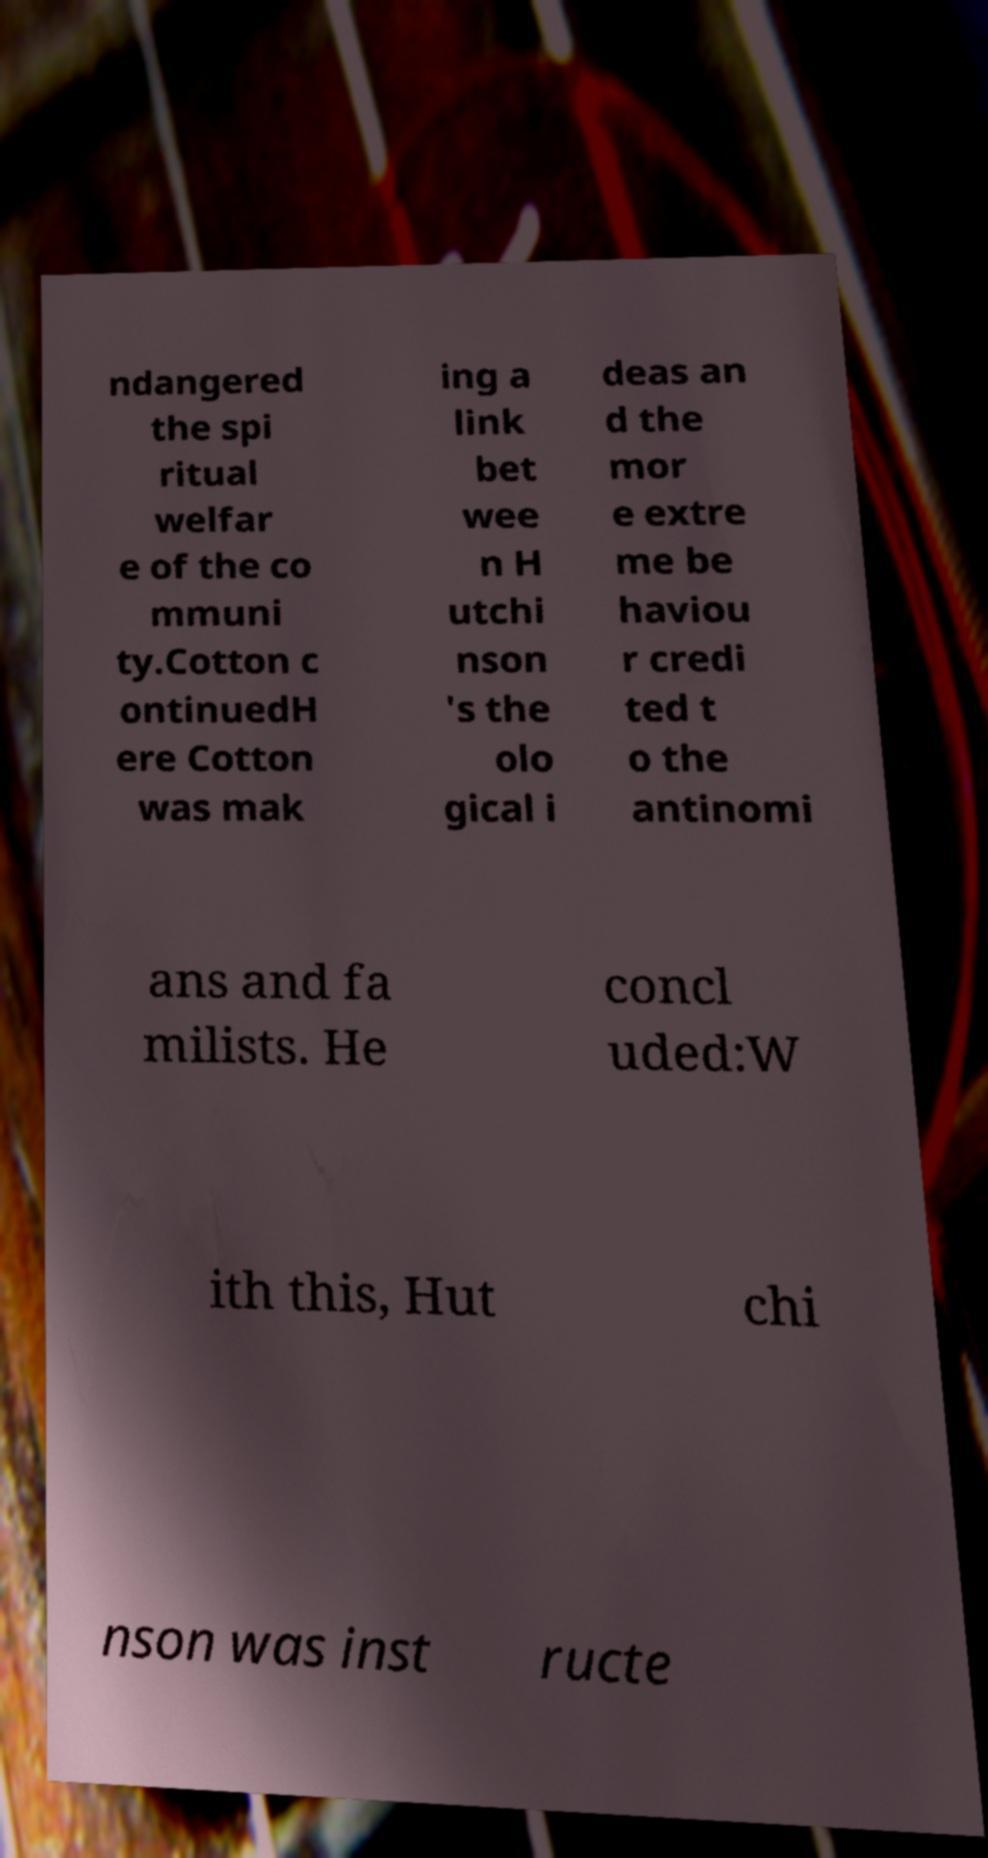Can you accurately transcribe the text from the provided image for me? ndangered the spi ritual welfar e of the co mmuni ty.Cotton c ontinuedH ere Cotton was mak ing a link bet wee n H utchi nson 's the olo gical i deas an d the mor e extre me be haviou r credi ted t o the antinomi ans and fa milists. He concl uded:W ith this, Hut chi nson was inst ructe 